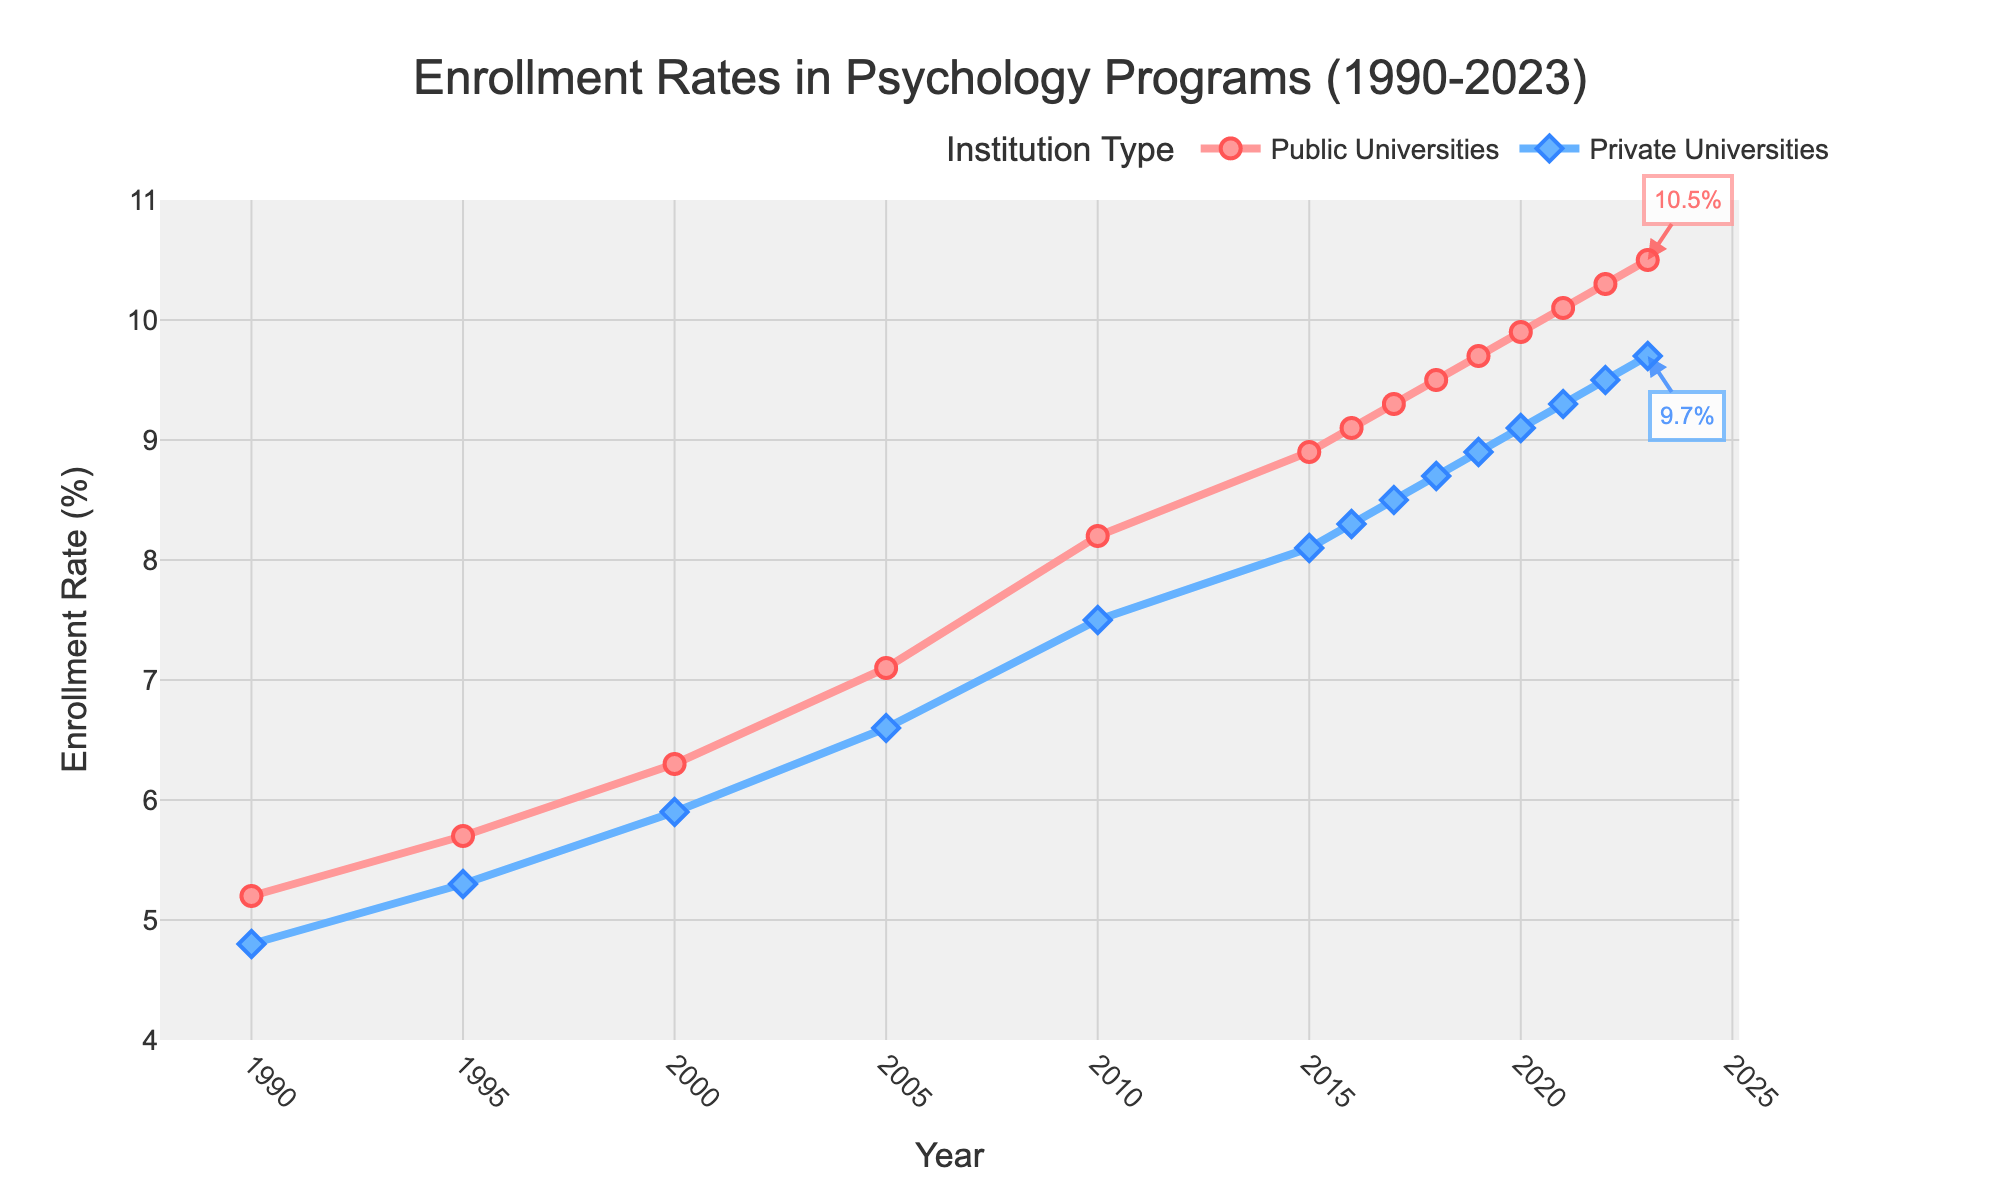How did the enrollment rates in public universities change from 1990 to 2023? To find out how the enrollment rates in public universities have changed over time, we look at the values at the beginning and end of the time period. In 1990, the rate was 5.2%, and in 2023, it became 10.5%. Therefore, it increased by 10.5% - 5.2% = 5.3%.
Answer: Increased by 5.3% Which year did the enrollment rate of private universities first reach 9%? By examining the line for private universities, we can see that the enrollment rate reached 9% between 2019 and 2020. In specific, in the year 2020, the rate was exactly 9.1%.
Answer: 2020 Which institution types had higher enrollment rates in 2015, and by how much? In 2015, the enrollment rate for public universities was 8.9% and for private universities was 8.1%. The difference is 8.9% - 8.1% = 0.8%.
Answer: Public universities by 0.8% Between 2010 and 2020, during which year did public universities see the most significant increase in enrollment rates? By examining the data points between 2010 and 2020, the change in enrollment rates year by year is visible. The largest increase is seen from 2010 (8.2%) to 2015 (8.9%), which is an increase of 0.7%.
Answer: 2015 What is the average enrollment rate in public universities from 1990 to 2000? We need to average the values for public universities from 1990 (5.2%) to 2000 (6.3%). Sum of values: 5.2 + 5.7 + 6.3 = 17.2. Number of values: 3. Average = 17.2 / 3 = 5.73%
Answer: 5.73% In which year was the enrollment gap between public and private universities the smallest? The smallest gap can be identified by comparing the differences between the two lines year by year. The enrollment gap was smallest in 1990 with a difference of 5.2% - 4.8% = 0.4%.
Answer: 1990 Is the enrollment rate trend upward or downward for private universities from 1990 to 2023? Observing the entire duration from 1990 to 2023, the line representing private universities shows a general upward trend, increasing from 4.8% to 9.7%.
Answer: Upward By how much did the enrollment rate in private universities change between 1995 and 2023? From 1995 (5.3%) to 2023 (9.7%), the change in enrollment rate is 9.7% - 5.3% = 4.4%.
Answer: Increased by 4.4% How much higher was the enrollment rate for public universities compared to private universities in 2022? In 2022, the enrollment rate for public universities was 10.3% and for private universities was 9.5%. Difference is 10.3% - 9.5% = 0.8%.
Answer: 0.8% Which visual attributes distinguish the lines for public and private universities? The line for public universities is pink and represented by circles, while the line for private universities is blue and represented by diamonds.
Answer: Colors and markers 